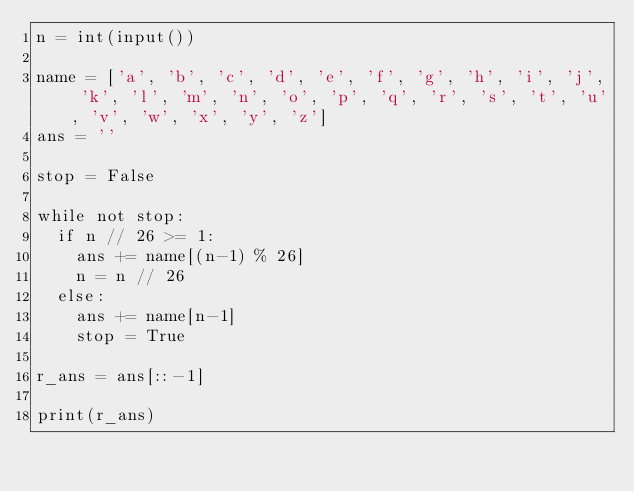Convert code to text. <code><loc_0><loc_0><loc_500><loc_500><_Python_>n = int(input())

name = ['a', 'b', 'c', 'd', 'e', 'f', 'g', 'h', 'i', 'j', 'k', 'l', 'm', 'n', 'o', 'p', 'q', 'r', 's', 't', 'u', 'v', 'w', 'x', 'y', 'z']
ans = ''

stop = False

while not stop: 
  if n // 26 >= 1:
    ans += name[(n-1) % 26]
    n = n // 26
  else:
    ans += name[n-1]
    stop = True

r_ans = ans[::-1]

print(r_ans)
</code> 